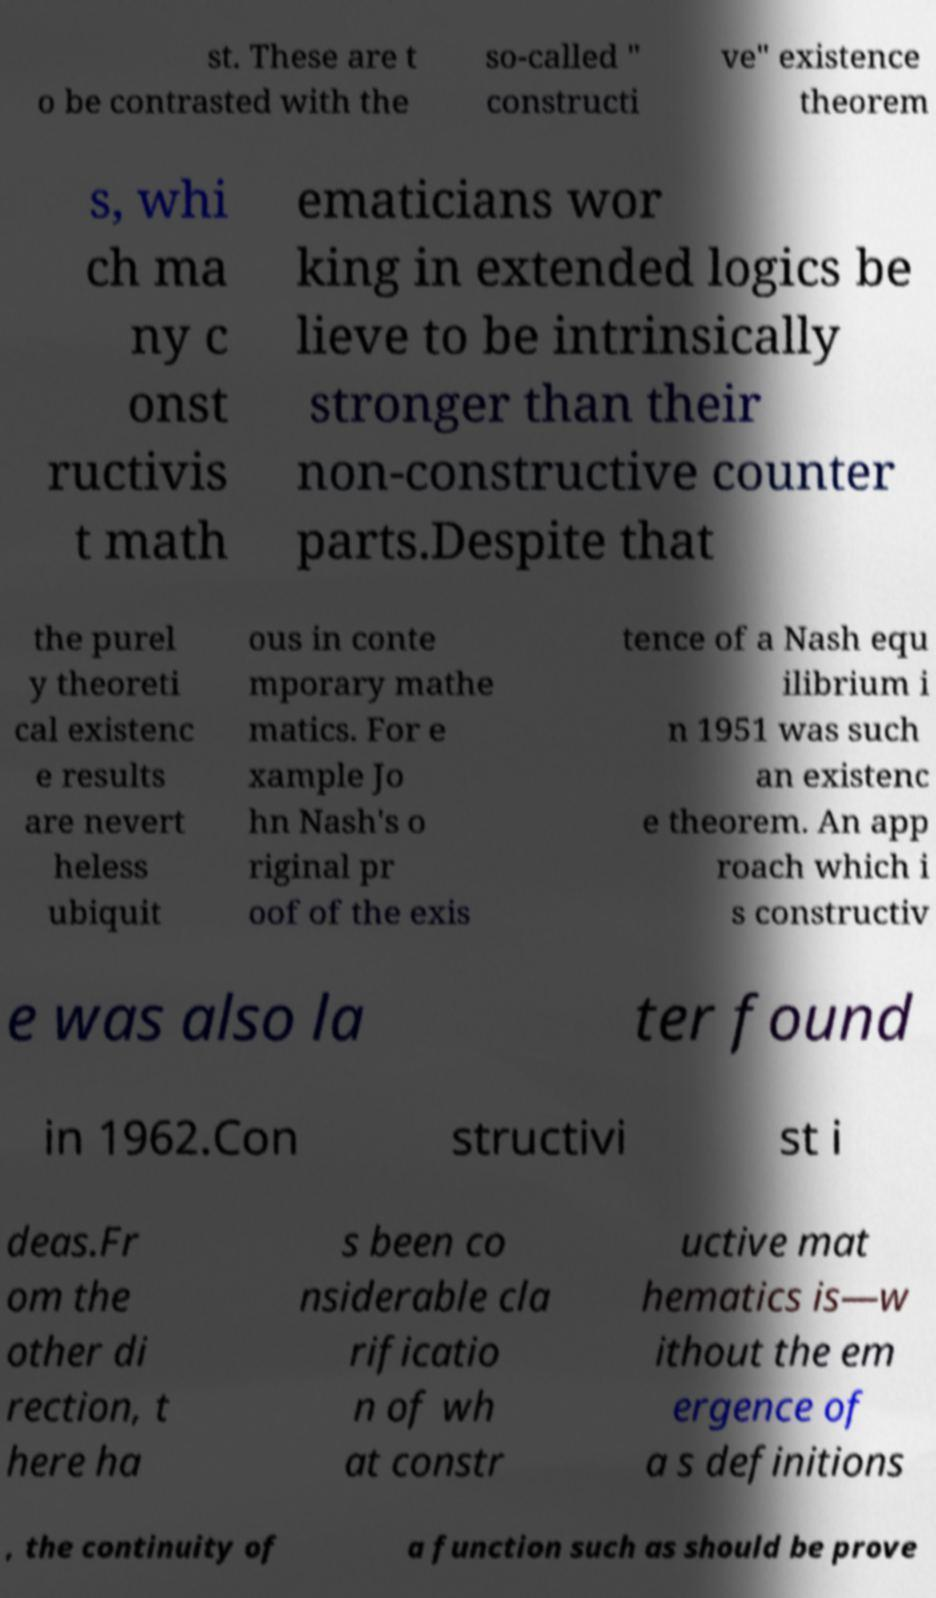For documentation purposes, I need the text within this image transcribed. Could you provide that? st. These are t o be contrasted with the so-called " constructi ve" existence theorem s, whi ch ma ny c onst ructivis t math ematicians wor king in extended logics be lieve to be intrinsically stronger than their non-constructive counter parts.Despite that the purel y theoreti cal existenc e results are nevert heless ubiquit ous in conte mporary mathe matics. For e xample Jo hn Nash's o riginal pr oof of the exis tence of a Nash equ ilibrium i n 1951 was such an existenc e theorem. An app roach which i s constructiv e was also la ter found in 1962.Con structivi st i deas.Fr om the other di rection, t here ha s been co nsiderable cla rificatio n of wh at constr uctive mat hematics is—w ithout the em ergence of a s definitions , the continuity of a function such as should be prove 